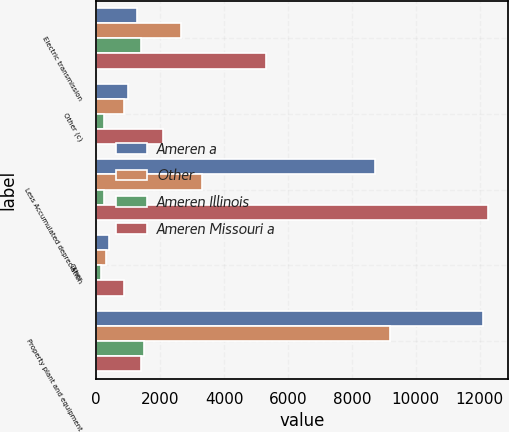Convert chart to OTSL. <chart><loc_0><loc_0><loc_500><loc_500><stacked_bar_chart><ecel><fcel>Electric transmission<fcel>Other (c)<fcel>Less Accumulated depreciation<fcel>Other<fcel>Property plant and equipment<nl><fcel>Ameren a<fcel>1277<fcel>1008<fcel>8726<fcel>406<fcel>12103<nl><fcel>Other<fcel>2647<fcel>863<fcel>3294<fcel>311<fcel>9198<nl><fcel>Ameren Illinois<fcel>1385<fcel>230<fcel>253<fcel>147<fcel>1509<nl><fcel>Ameren Missouri a<fcel>5309<fcel>2101<fcel>12273<fcel>864<fcel>1385<nl></chart> 